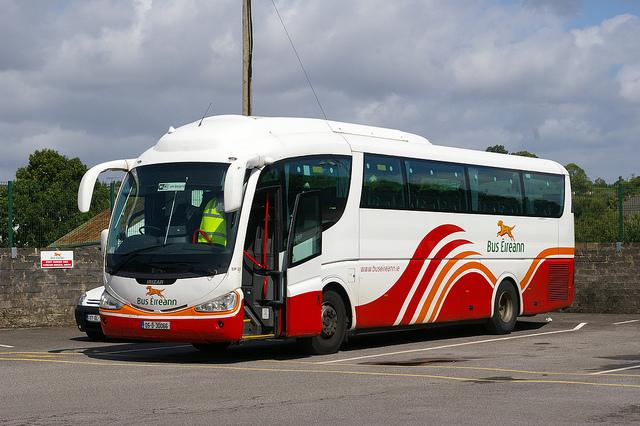Why is the man wearing a yellow vest?

Choices:
A) costume
B) disguise
C) visibility
D) fashion visibility 